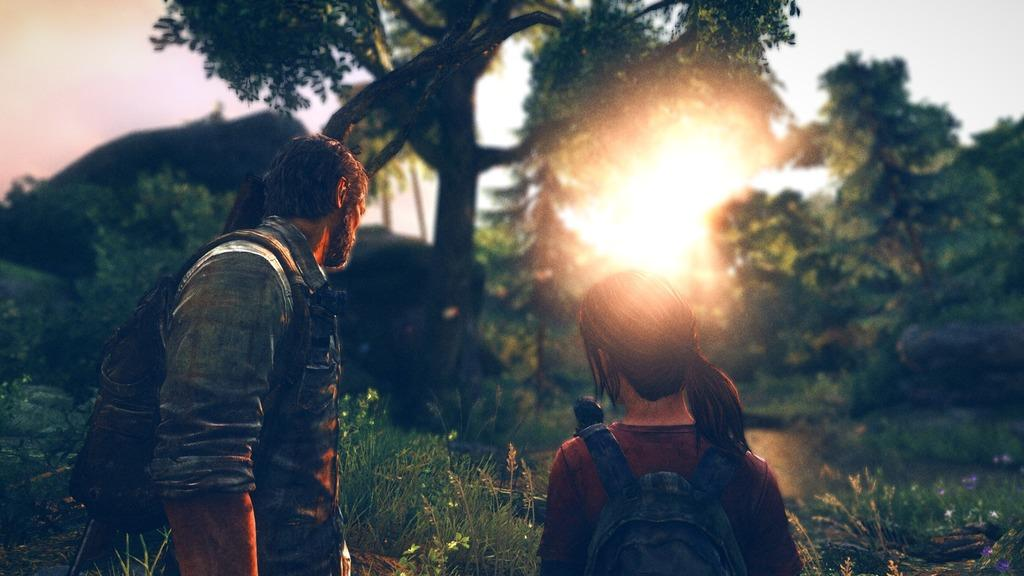How many people are present in the image? There are two people in the image. What can be seen in the background of the image? There are trees and the sunrise visible in the background of the image. How many pizzas are being held by the people in the image? There are no pizzas present in the image; it only features two people and a background with trees and a sunrise. 